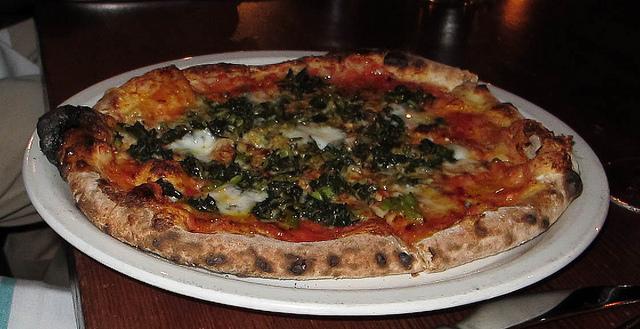Are they olives in the lower center of this scene?
Give a very brief answer. No. Is this a thin crust pizza?
Be succinct. Yes. Are there any slices missing?
Concise answer only. No. What color is the pizza plate?
Short answer required. White. What is the green stuff on the pizza?
Keep it brief. Spinach. What vegetables are on the pizza?
Be succinct. Spinach. Is this a vegetable pizza?
Short answer required. Yes. Has the pizza been delivered?
Short answer required. Yes. What color is the plate?
Write a very short answer. White. What are the pizzas on?
Give a very brief answer. Plate. What meat is on the pizza?
Quick response, please. Sausage. What is in the middle of the pizza?
Quick response, please. Spinach. 